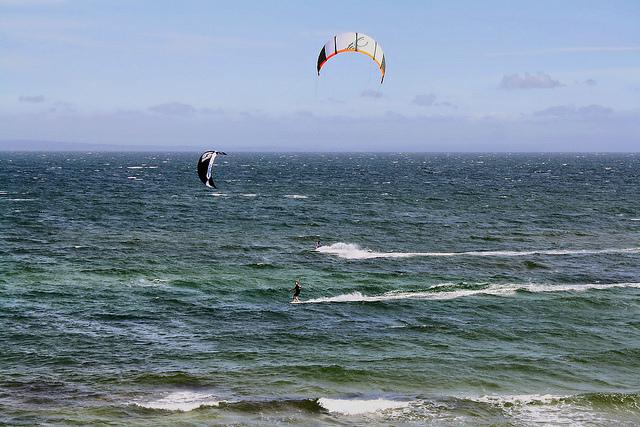How is the sea?
Give a very brief answer. Calm. Is it windy?
Be succinct. Yes. Are seagulls visible in the photo?
Write a very short answer. No. 